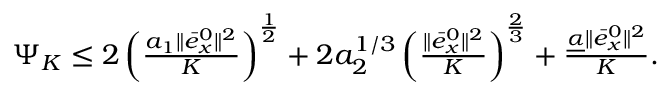<formula> <loc_0><loc_0><loc_500><loc_500>\begin{array} { r } { \Psi _ { K } \leq 2 \left ( \frac { a _ { 1 } \| \bar { e } _ { x } ^ { 0 } \| ^ { 2 } } { K } \right ) ^ { \frac { 1 } { 2 } } + 2 a _ { 2 } ^ { 1 / 3 } \left ( \frac { \| \bar { e } _ { x } ^ { 0 } \| ^ { 2 } } { K } \right ) ^ { \frac { 2 } { 3 } } + \frac { \underline { \alpha } \| \bar { e } _ { x } ^ { 0 } \| ^ { 2 } } { K } . } \end{array}</formula> 